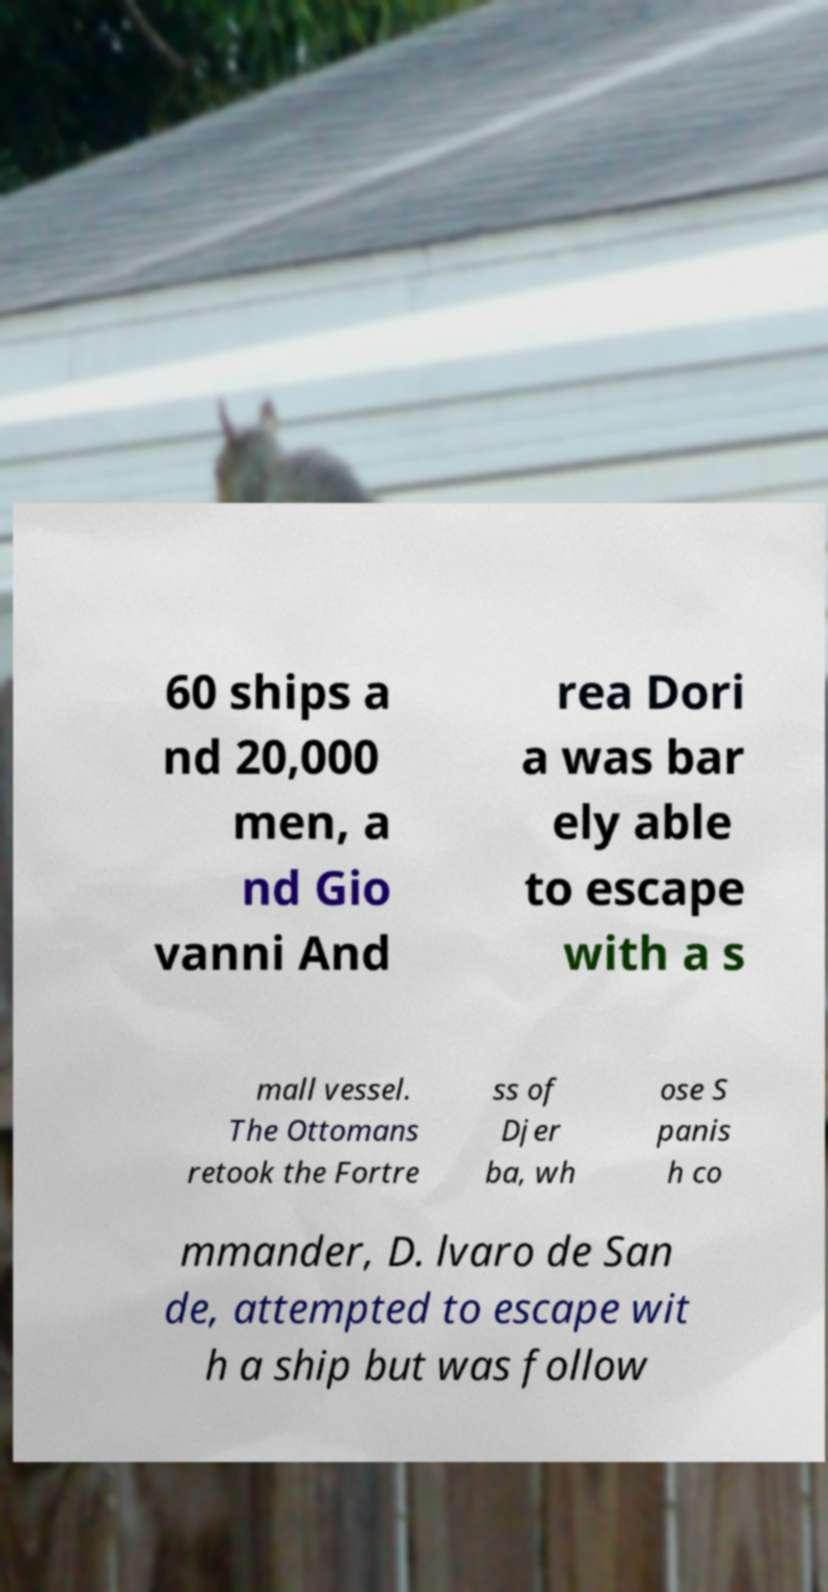What messages or text are displayed in this image? I need them in a readable, typed format. 60 ships a nd 20,000 men, a nd Gio vanni And rea Dori a was bar ely able to escape with a s mall vessel. The Ottomans retook the Fortre ss of Djer ba, wh ose S panis h co mmander, D. lvaro de San de, attempted to escape wit h a ship but was follow 